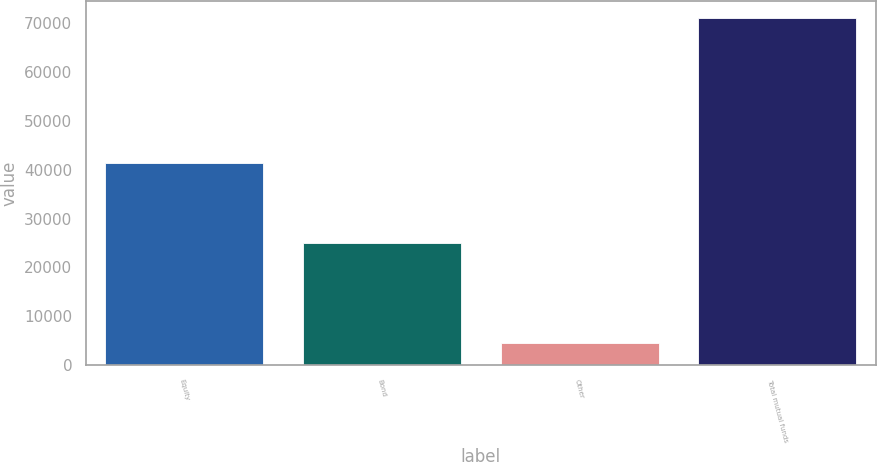Convert chart. <chart><loc_0><loc_0><loc_500><loc_500><bar_chart><fcel>Equity<fcel>Bond<fcel>Other<fcel>Total mutual funds<nl><fcel>41403<fcel>25060<fcel>4490<fcel>70953<nl></chart> 